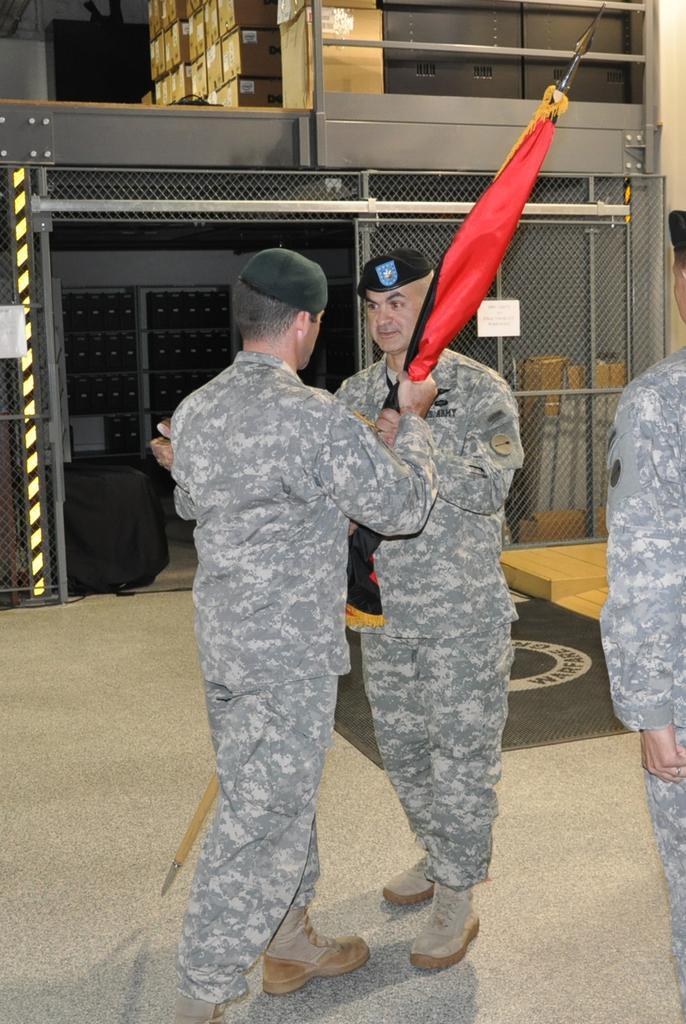In one or two sentences, can you explain what this image depicts? In this image we can see a group of people wearing military uniforms and caps is standing on the floor. One person is holding a flag in his hands. In the background, we can see a gate, a group of objects placed on racks, group of cardboard boxes placed on the surface and some metal poles. 